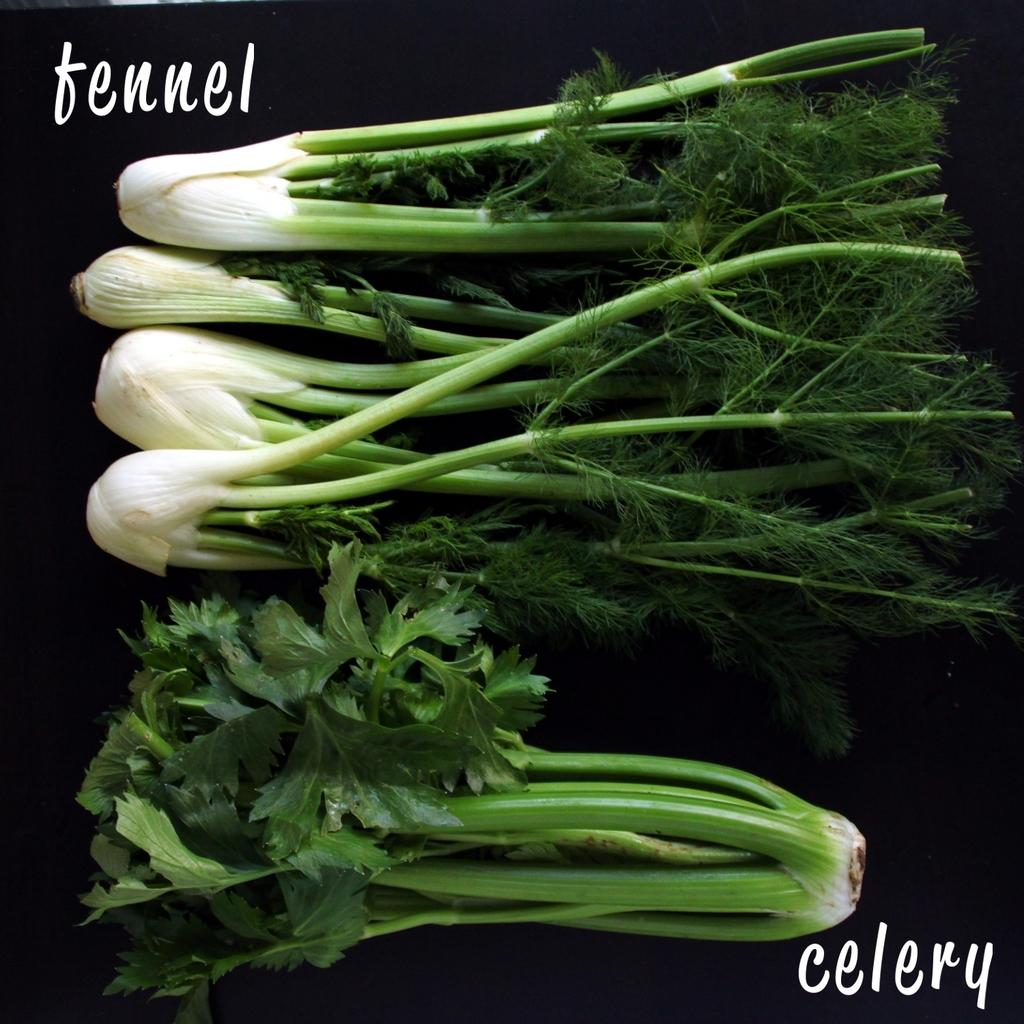What type of vegetable is present in the image? There are radishes in the image. What can be observed about the background of the image? The background of the image is dark. Are there any words or letters visible in the image? Yes, there is text visible in the image. What type of metal can be seen on the sidewalk in the image? There is no sidewalk or metal present in the image; it features radishes and text against a dark background. 